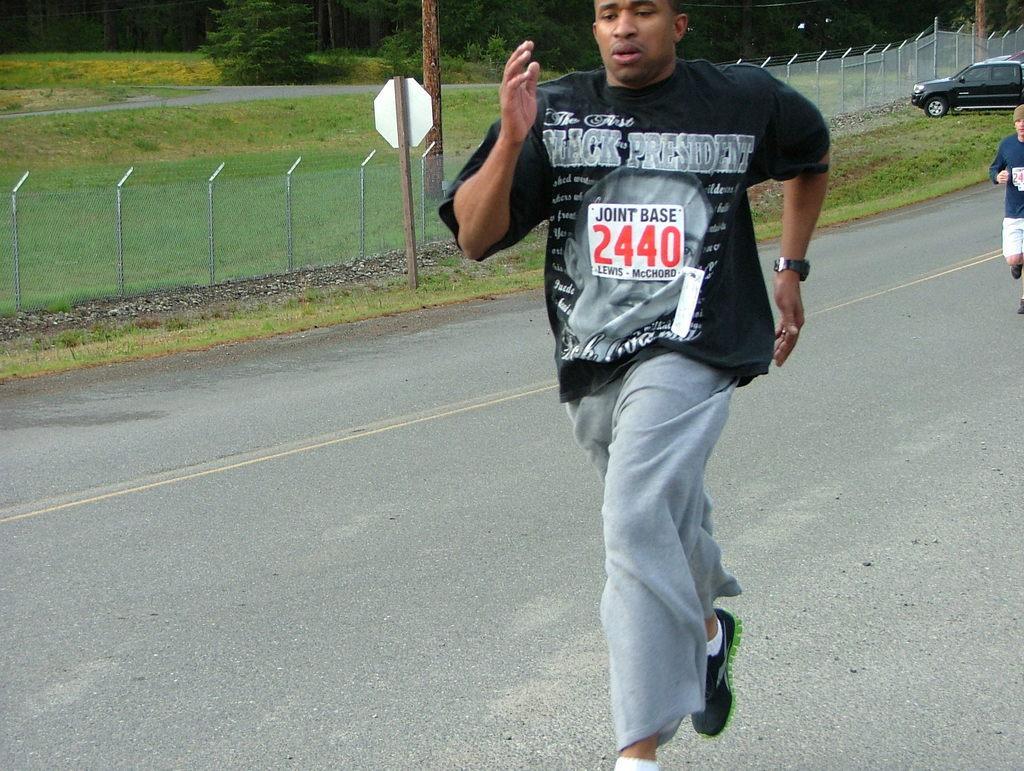Please provide a concise description of this image. In this image we can see the two persons running on the road, there are some trees, poles, fence, grass, board and a vehicle, 